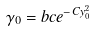Convert formula to latex. <formula><loc_0><loc_0><loc_500><loc_500>\gamma _ { 0 } = b c e ^ { - C y _ { 0 } ^ { 2 } }</formula> 